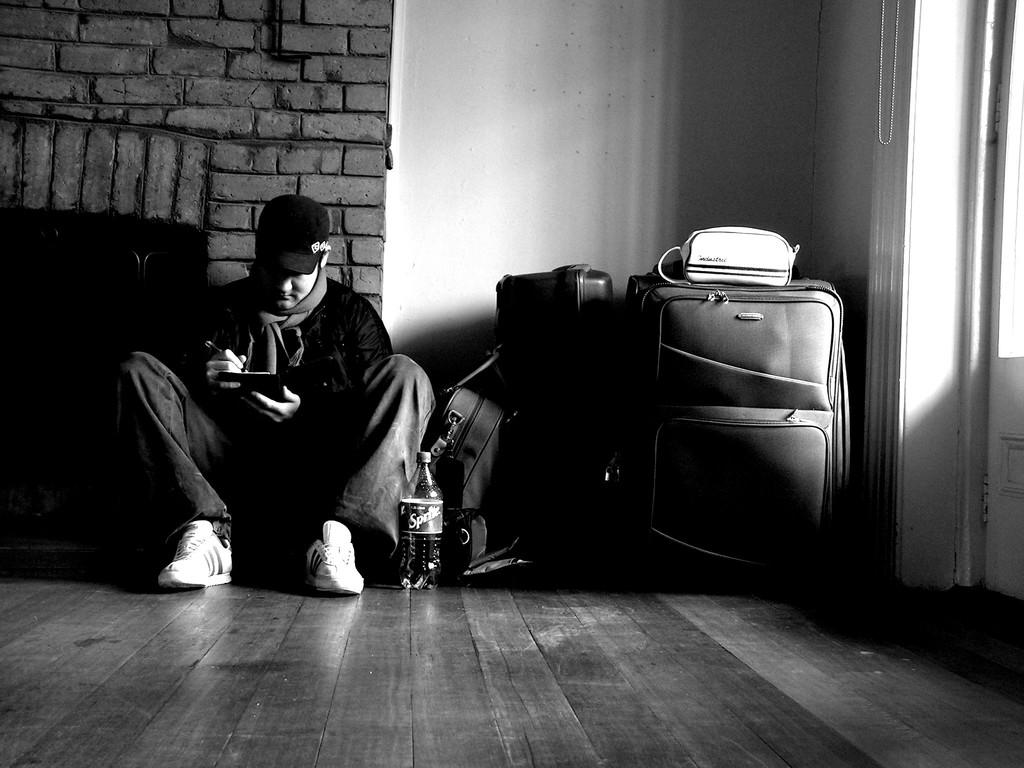What is the man in the image doing? The man is seated on the ground in the image. What is located in front of the man? There is a bottle and some baggage in front of the man. What can be seen in the background of the image? There is a wall visible in the background of the image. What type of vegetable is the man holding in the image? There is no vegetable present in the image; the man is seated on the ground with a bottle and baggage in front of him. 